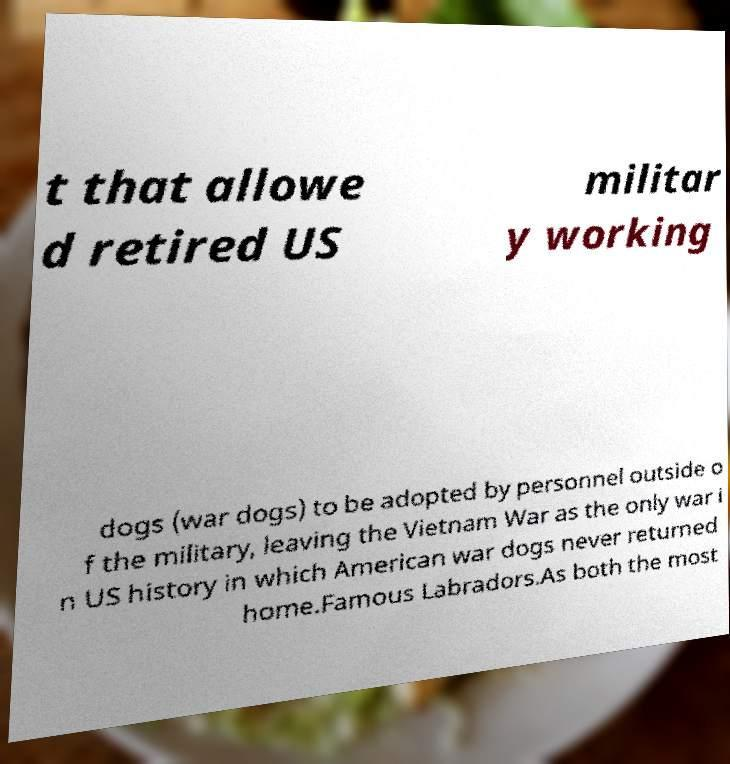What messages or text are displayed in this image? I need them in a readable, typed format. t that allowe d retired US militar y working dogs (war dogs) to be adopted by personnel outside o f the military, leaving the Vietnam War as the only war i n US history in which American war dogs never returned home.Famous Labradors.As both the most 